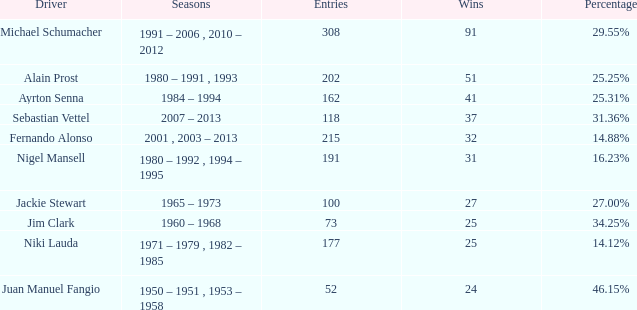Which driver possesses 162 entries? Ayrton Senna. 